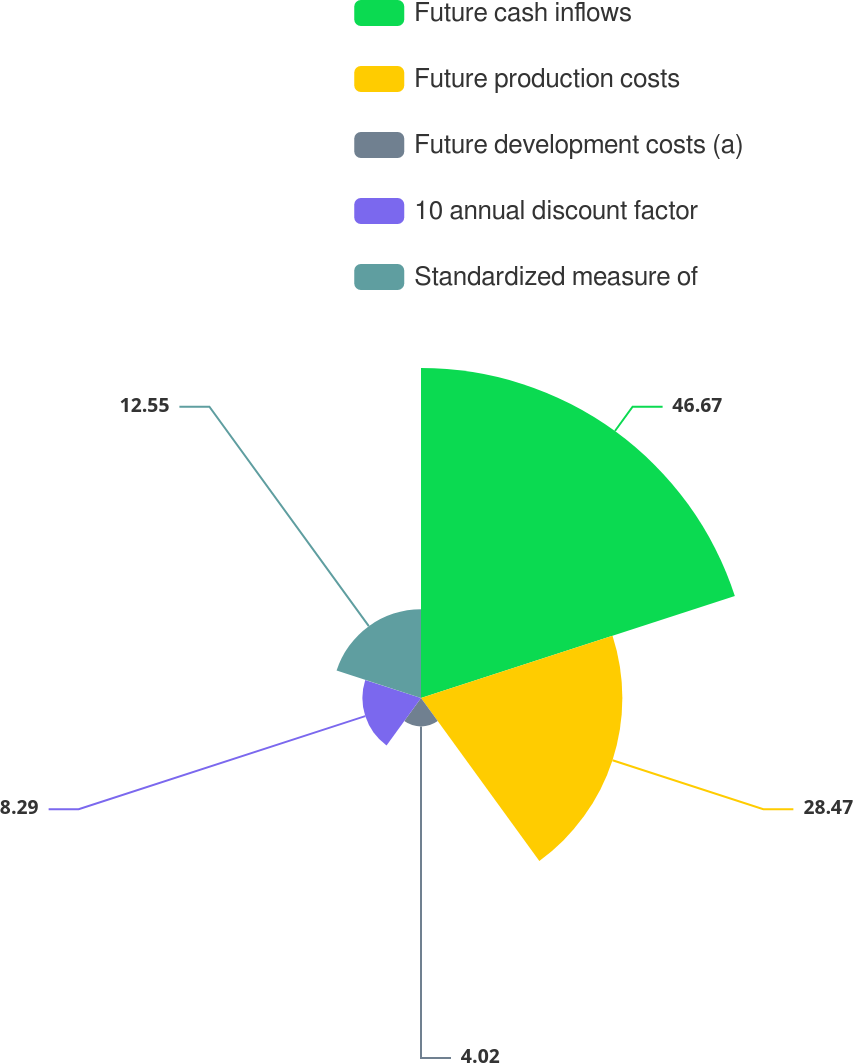Convert chart. <chart><loc_0><loc_0><loc_500><loc_500><pie_chart><fcel>Future cash inflows<fcel>Future production costs<fcel>Future development costs (a)<fcel>10 annual discount factor<fcel>Standardized measure of<nl><fcel>46.66%<fcel>28.47%<fcel>4.02%<fcel>8.29%<fcel>12.55%<nl></chart> 